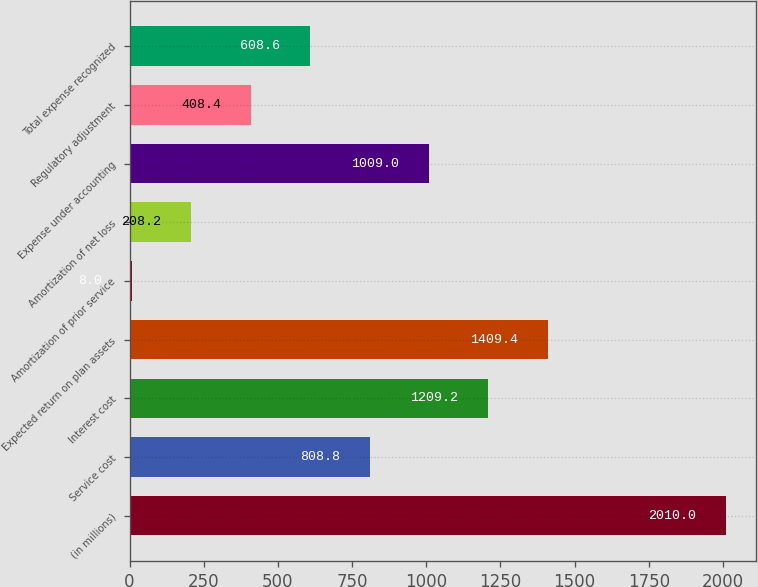<chart> <loc_0><loc_0><loc_500><loc_500><bar_chart><fcel>(in millions)<fcel>Service cost<fcel>Interest cost<fcel>Expected return on plan assets<fcel>Amortization of prior service<fcel>Amortization of net loss<fcel>Expense under accounting<fcel>Regulatory adjustment<fcel>Total expense recognized<nl><fcel>2010<fcel>808.8<fcel>1209.2<fcel>1409.4<fcel>8<fcel>208.2<fcel>1009<fcel>408.4<fcel>608.6<nl></chart> 